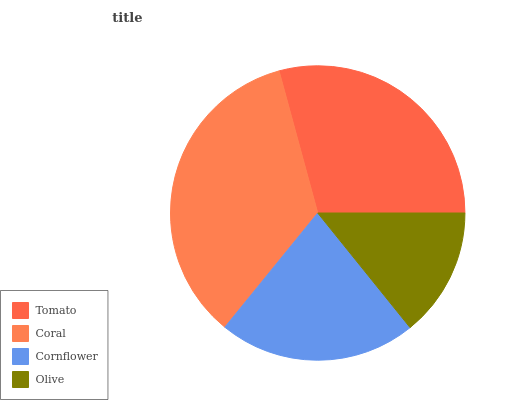Is Olive the minimum?
Answer yes or no. Yes. Is Coral the maximum?
Answer yes or no. Yes. Is Cornflower the minimum?
Answer yes or no. No. Is Cornflower the maximum?
Answer yes or no. No. Is Coral greater than Cornflower?
Answer yes or no. Yes. Is Cornflower less than Coral?
Answer yes or no. Yes. Is Cornflower greater than Coral?
Answer yes or no. No. Is Coral less than Cornflower?
Answer yes or no. No. Is Tomato the high median?
Answer yes or no. Yes. Is Cornflower the low median?
Answer yes or no. Yes. Is Coral the high median?
Answer yes or no. No. Is Tomato the low median?
Answer yes or no. No. 